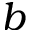<formula> <loc_0><loc_0><loc_500><loc_500>b</formula> 